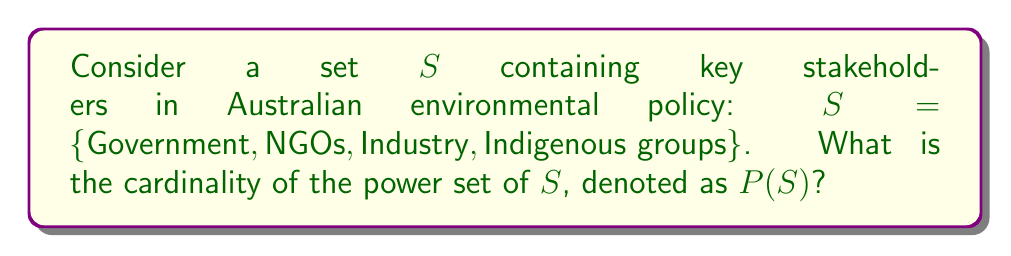What is the answer to this math problem? To solve this problem, let's follow these steps:

1) First, recall that the power set of a set $S$ is the set of all possible subsets of $S$, including the empty set and $S$ itself.

2) The cardinality of set $S$ is 4, as it contains 4 elements.

3) For any set with $n$ elements, the cardinality of its power set is given by the formula:

   $$|P(S)| = 2^n$$

   Where $|P(S)|$ represents the cardinality of the power set of $S$.

4) In this case, $n = 4$, so we can calculate:

   $$|P(S)| = 2^4 = 16$$

5) To verify this, we can list all possible subsets:
   - Empty set: $\{\}$
   - 4 subsets with 1 element: $\{\text{Government}\}$, $\{\text{NGOs}\}$, $\{\text{Industry}\}$, $\{\text{Indigenous groups}\}$
   - 6 subsets with 2 elements: $\{\text{Government, NGOs}\}$, $\{\text{Government, Industry}\}$, $\{\text{Government, Indigenous groups}\}$, $\{\text{NGOs, Industry}\}$, $\{\text{NGOs, Indigenous groups}\}$, $\{\text{Industry, Indigenous groups}\}$
   - 4 subsets with 3 elements: $\{\text{Government, NGOs, Industry}\}$, $\{\text{Government, NGOs, Indigenous groups}\}$, $\{\text{Government, Industry, Indigenous groups}\}$, $\{\text{NGOs, Industry, Indigenous groups}\}$
   - 1 subset with 4 elements: $\{\text{Government, NGOs, Industry, Indigenous groups}\}$

   Indeed, the total number of subsets is $1 + 4 + 6 + 4 + 1 = 16$.

Therefore, the cardinality of the power set of $S$ is 16.
Answer: $|P(S)| = 16$ 